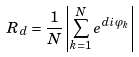<formula> <loc_0><loc_0><loc_500><loc_500>R _ { d } = \frac { 1 } { N } \left | \sum _ { k = 1 } ^ { N } e ^ { d i \varphi _ { k } } \right |</formula> 